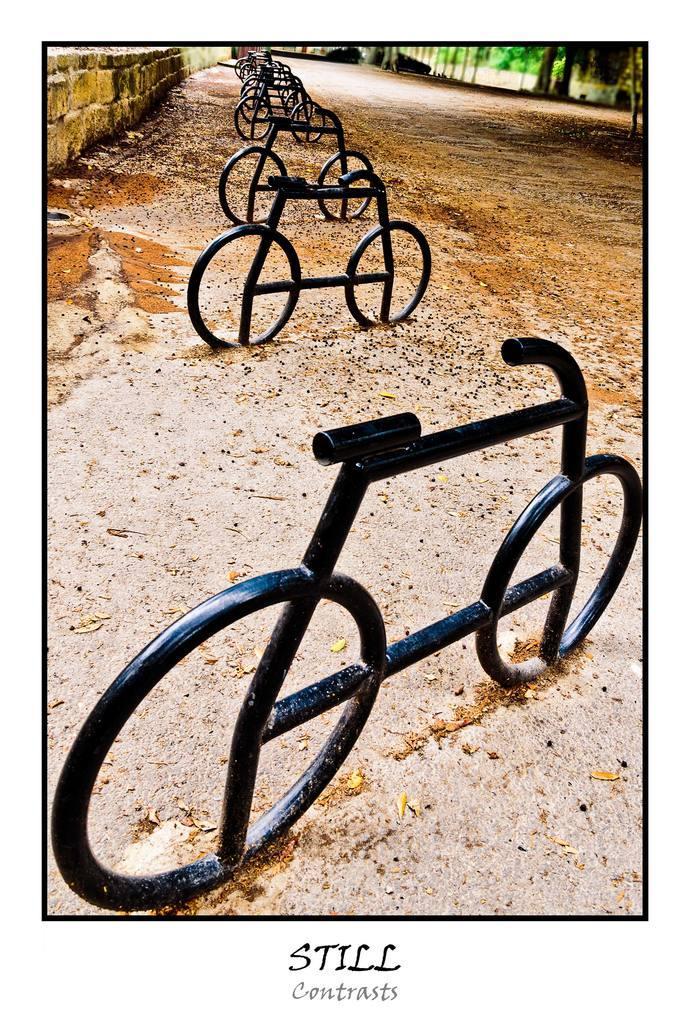Could you give a brief overview of what you see in this image? In this picture we can see few metal rods and trees, at the bottom of the image we can find some text. 